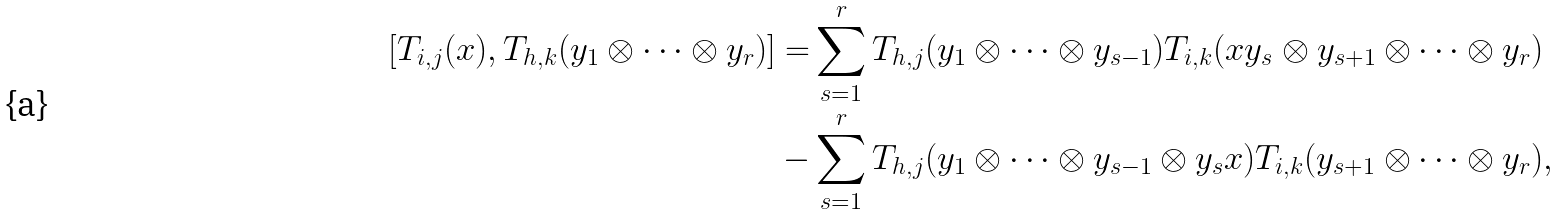<formula> <loc_0><loc_0><loc_500><loc_500>[ T _ { i , j } ( x ) , T _ { h , k } ( y _ { 1 } \otimes \cdots \otimes y _ { r } ) ] = & \sum _ { s = 1 } ^ { r } T _ { h , j } ( y _ { 1 } \otimes \cdots \otimes y _ { s - 1 } ) T _ { i , k } ( x y _ { s } \otimes y _ { s + 1 } \otimes \cdots \otimes y _ { r } ) \\ - & \sum _ { s = 1 } ^ { r } T _ { h , j } ( y _ { 1 } \otimes \cdots \otimes y _ { s - 1 } \otimes y _ { s } x ) T _ { i , k } ( y _ { s + 1 } \otimes \cdots \otimes y _ { r } ) ,</formula> 